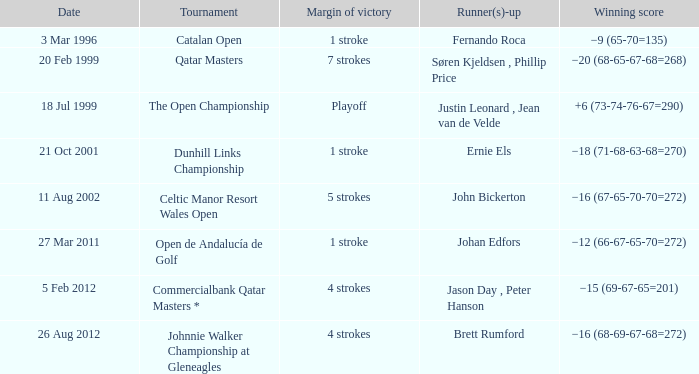What tournament that Fernando Roca is the runner-up? Catalan Open. 